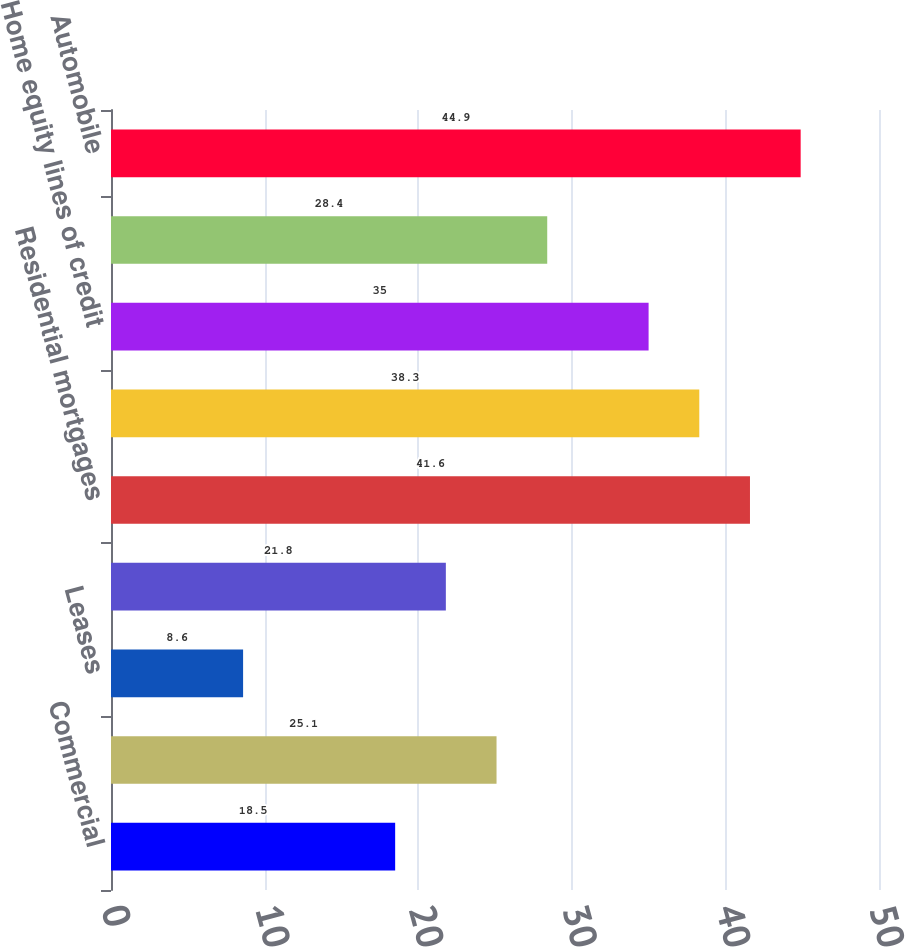Convert chart. <chart><loc_0><loc_0><loc_500><loc_500><bar_chart><fcel>Commercial<fcel>Commercial real estate<fcel>Leases<fcel>Total commercial<fcel>Residential mortgages<fcel>Home equity loans<fcel>Home equity lines of credit<fcel>Home equity loans serviced by<fcel>Automobile<nl><fcel>18.5<fcel>25.1<fcel>8.6<fcel>21.8<fcel>41.6<fcel>38.3<fcel>35<fcel>28.4<fcel>44.9<nl></chart> 